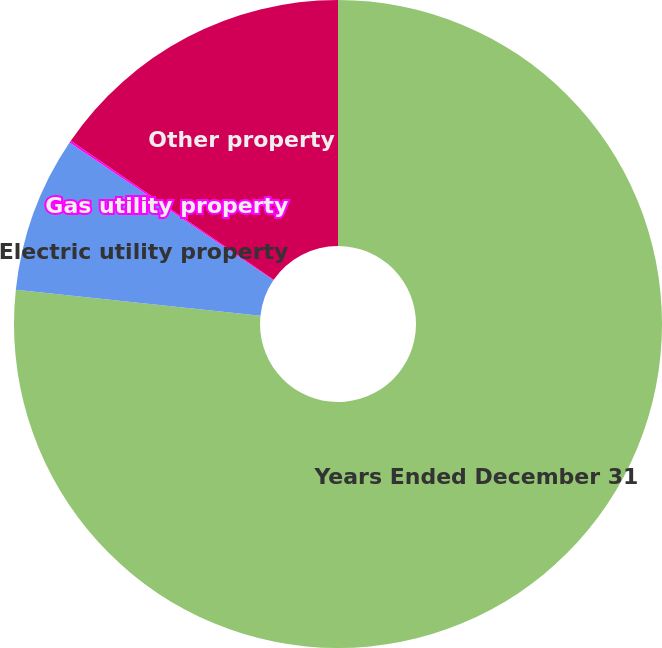<chart> <loc_0><loc_0><loc_500><loc_500><pie_chart><fcel>Years Ended December 31<fcel>Electric utility property<fcel>Gas utility property<fcel>Other property<nl><fcel>76.69%<fcel>7.77%<fcel>0.11%<fcel>15.43%<nl></chart> 